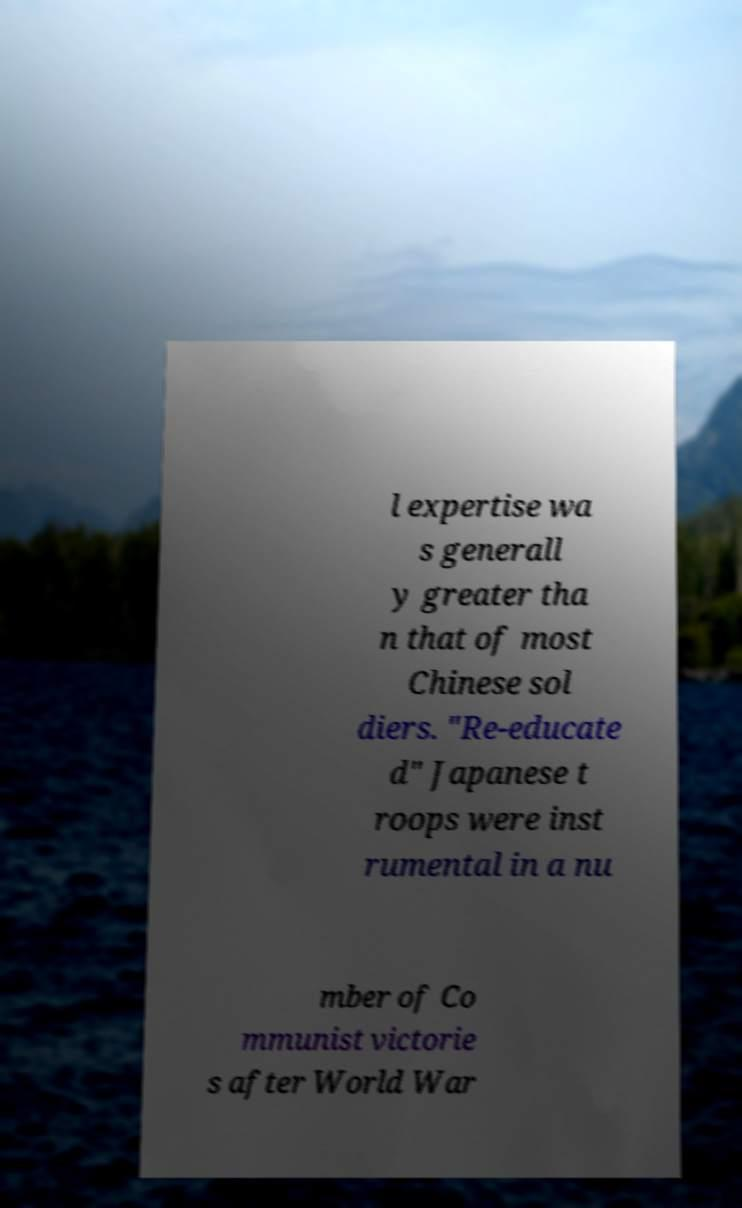Could you assist in decoding the text presented in this image and type it out clearly? l expertise wa s generall y greater tha n that of most Chinese sol diers. "Re-educate d" Japanese t roops were inst rumental in a nu mber of Co mmunist victorie s after World War 